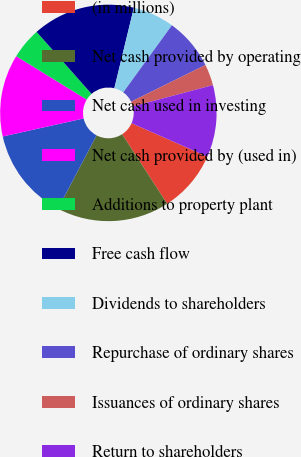Convert chart. <chart><loc_0><loc_0><loc_500><loc_500><pie_chart><fcel>(in millions)<fcel>Net cash provided by operating<fcel>Net cash used in investing<fcel>Net cash provided by (used in)<fcel>Additions to property plant<fcel>Free cash flow<fcel>Dividends to shareholders<fcel>Repurchase of ordinary shares<fcel>Issuances of ordinary shares<fcel>Return to shareholders<nl><fcel>9.24%<fcel>16.84%<fcel>13.8%<fcel>12.28%<fcel>4.68%<fcel>15.32%<fcel>6.2%<fcel>7.72%<fcel>3.16%<fcel>10.76%<nl></chart> 